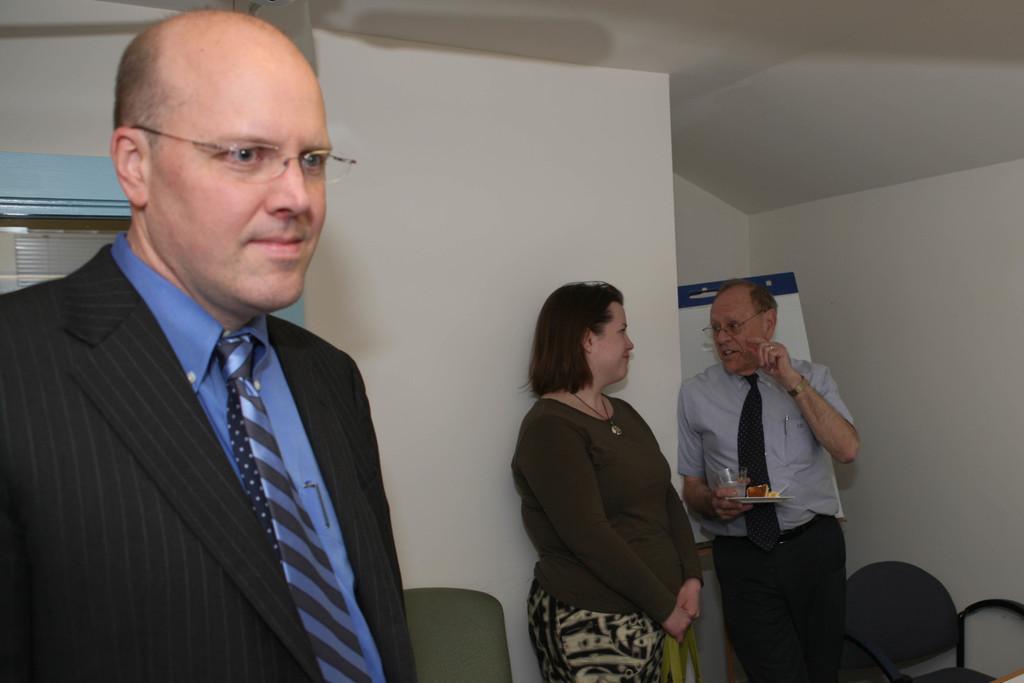How would you summarize this image in a sentence or two? In the image we can see there are people standing and there are chairs kept on the floor. Behind there is a person holding plate in which food items are kept and there is banner kept on the floor. 